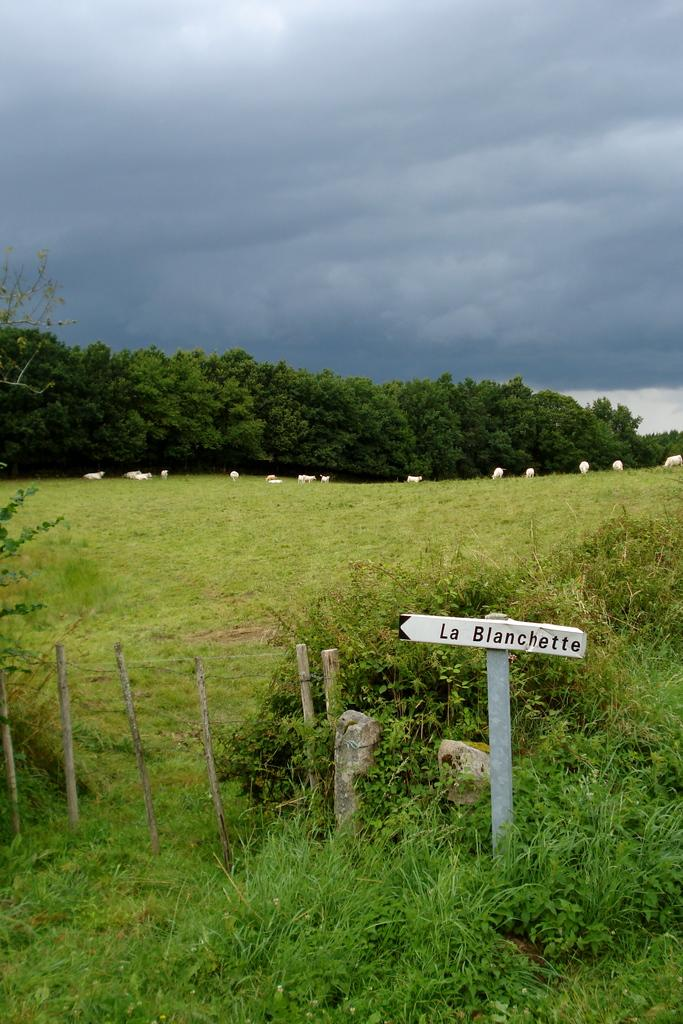What type of ground is visible at the bottom of the image? There is grass at the bottom of the image. What object is also present at the bottom of the image? There is a board at the bottom of the image. What can be seen in the distance in the image? There are trees in the background of the image. What part of the natural environment is visible in the background of the image? The sky is visible in the background of the image. How does the person in the image grip the grass? There is no person present in the image, so it is not possible to determine how they would grip the grass. 